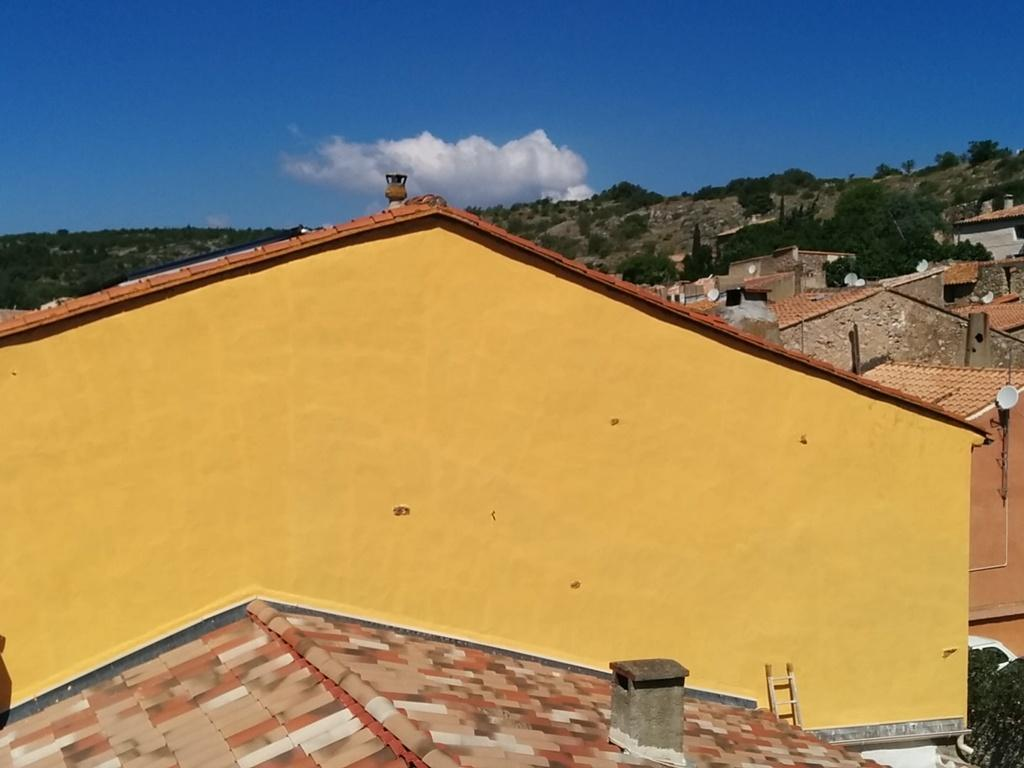What type of structures can be seen in the image? There are houses in the image. What can be seen in the distance behind the houses? There are mountains and trees in the background of the image. What is visible in the sky in the image? There are clouds in the sky. How many cows can be seen grazing in the image? There are no cows present in the image. What is the altitude of the train in the image? There is no train present in the image. 